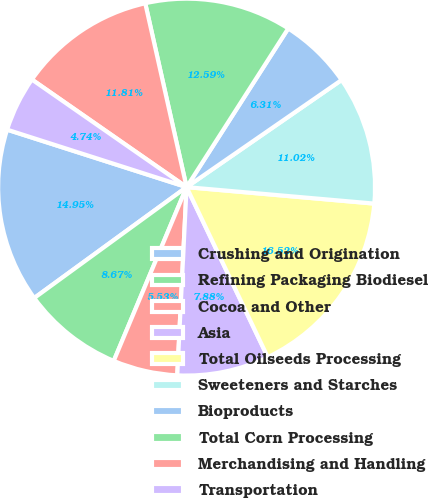Convert chart. <chart><loc_0><loc_0><loc_500><loc_500><pie_chart><fcel>Crushing and Origination<fcel>Refining Packaging Biodiesel<fcel>Cocoa and Other<fcel>Asia<fcel>Total Oilseeds Processing<fcel>Sweeteners and Starches<fcel>Bioproducts<fcel>Total Corn Processing<fcel>Merchandising and Handling<fcel>Transportation<nl><fcel>14.95%<fcel>8.67%<fcel>5.53%<fcel>7.88%<fcel>16.52%<fcel>11.02%<fcel>6.31%<fcel>12.59%<fcel>11.81%<fcel>4.74%<nl></chart> 